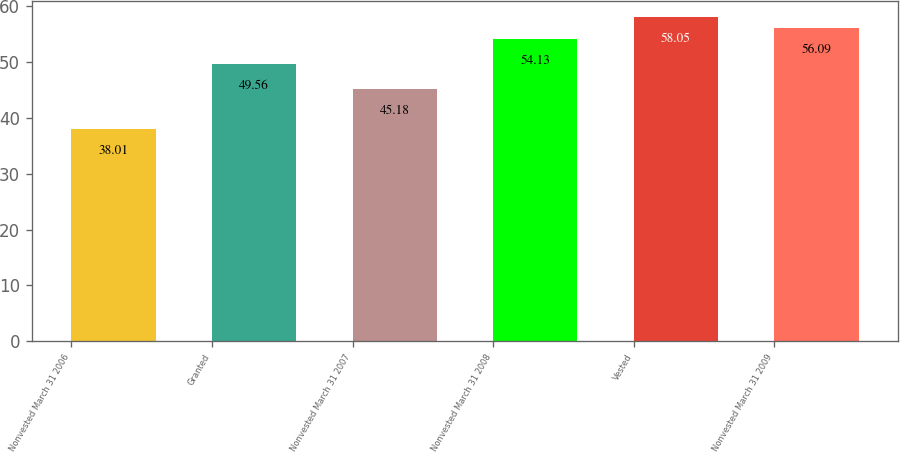<chart> <loc_0><loc_0><loc_500><loc_500><bar_chart><fcel>Nonvested March 31 2006<fcel>Granted<fcel>Nonvested March 31 2007<fcel>Nonvested March 31 2008<fcel>Vested<fcel>Nonvested March 31 2009<nl><fcel>38.01<fcel>49.56<fcel>45.18<fcel>54.13<fcel>58.05<fcel>56.09<nl></chart> 